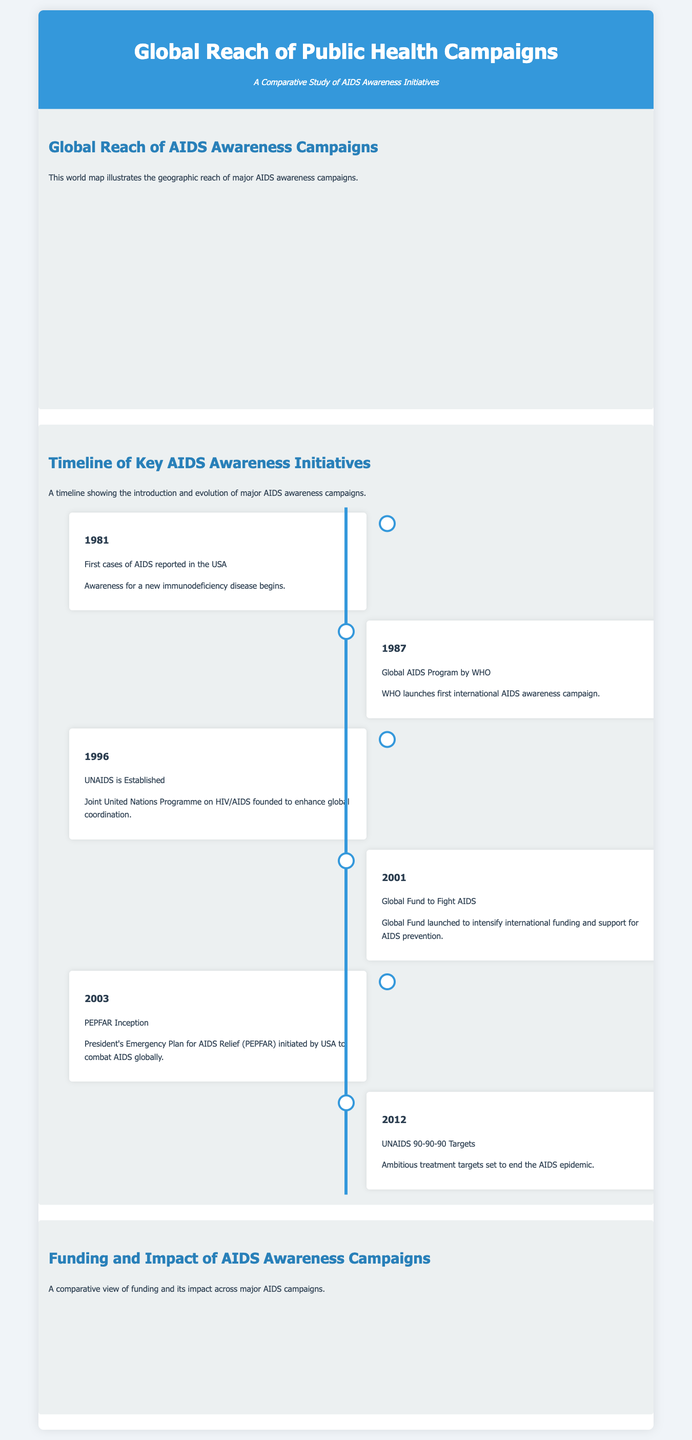What year were the first cases of AIDS reported in the USA? The document states that the first cases of AIDS were reported in 1981.
Answer: 1981 What organization launched the first international AIDS awareness campaign? According to the timeline, the WHO launched the first international AIDS awareness campaign in 1987.
Answer: WHO How much funding (in million USD) did PEPFAR receive? The funding data in the chart shows that PEPFAR received 7000 million USD.
Answer: 7000 million USD What percentage reach and effectiveness did the Global Fund achieve? The impact data in the chart states that the Global Fund had a reach and effectiveness percentage of 60%.
Answer: 60% Which initiative was established in 1996? The timeline indicates that UNAIDS was established in 1996.
Answer: UNAIDS What is the color representing funding in the bar chart? The chart legend specifies that the color for funding is light blue.
Answer: Light blue Which country is marked as selected on the world map? The document mentions specific selected countries on the map, including the USA.
Answer: USA What is the title of the infographic? The title of the infographic is "Global Reach of Public Health Campaigns".
Answer: Global Reach of Public Health Campaigns What year did the UNAIDS 90-90-90 targets get set? The timeline indicates that the UNAIDS 90-90-90 targets were set in 2012.
Answer: 2012 